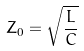<formula> <loc_0><loc_0><loc_500><loc_500>Z _ { 0 } = \sqrt { \frac { L } { C } }</formula> 